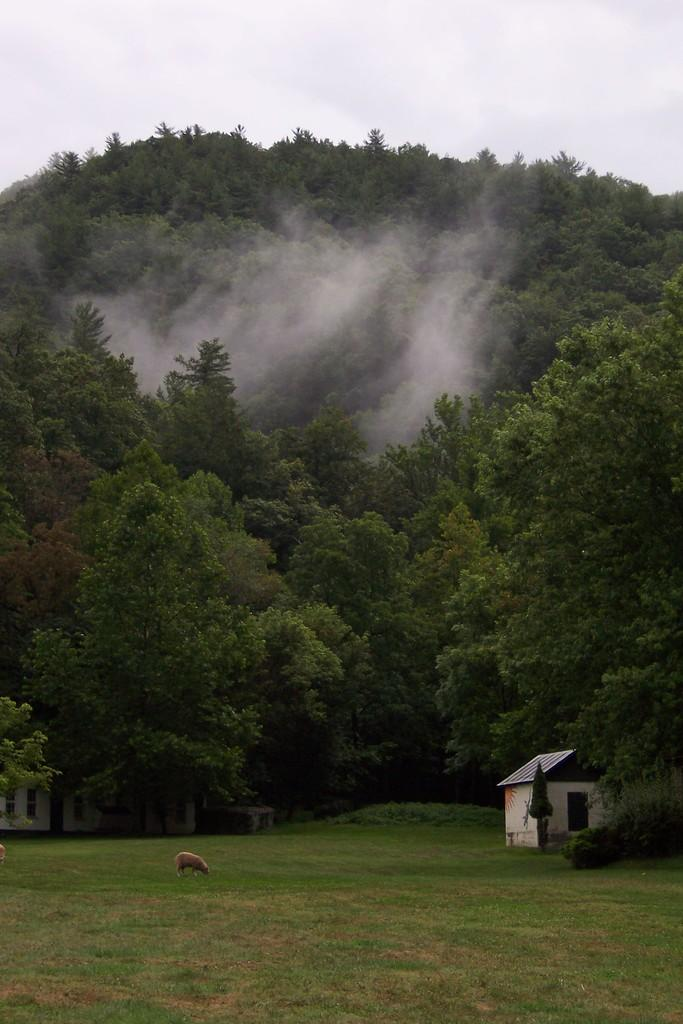What type of structures can be seen in the image? There are houses in the image. What is located on the ground in the image? There is an animal on the ground in the image. What color is the animal in the image? The animal is brown in color. What can be seen in the background of the image? There are many trees and the sky visible in the background of the image. What day of the week is depicted in the image? The image does not depict a specific day of the week; it is a still image without any indication of time. 